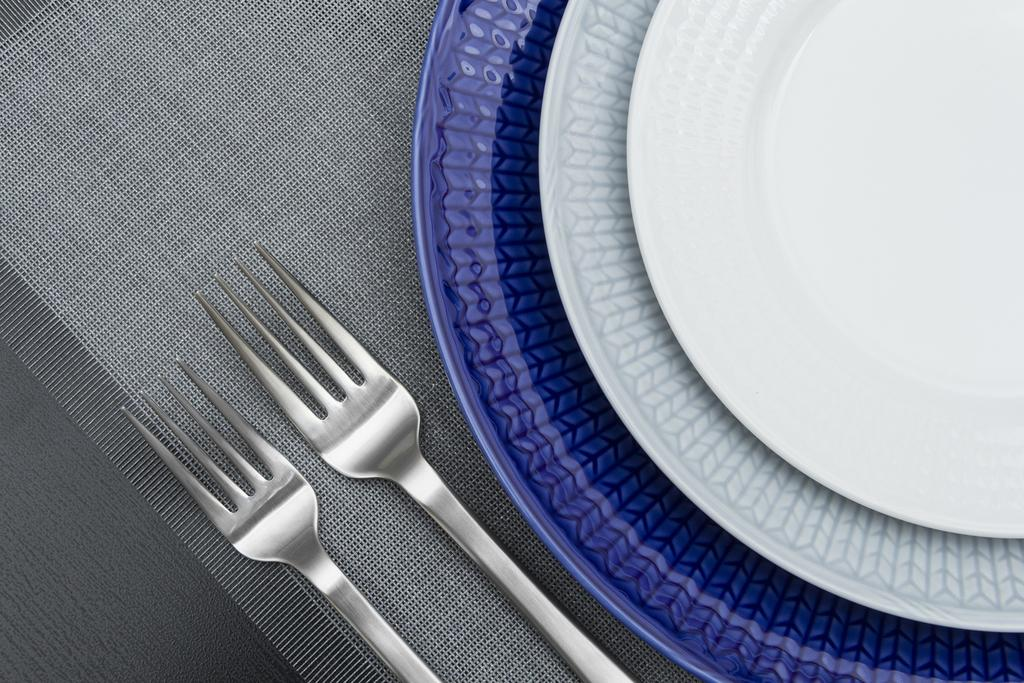What type of tableware can be seen in the image? There are plates in the image. What colors are the plates? The plates are violet and white in color. How many forks are present in the image? There are 2 forks in the image. What is the color of the surface where the plates and forks are placed? The plates and forks are on a white and grey color surface. What type of toy is being punished in the image? There is no toy or punishment present in the image; it only features plates and forks on a surface. 